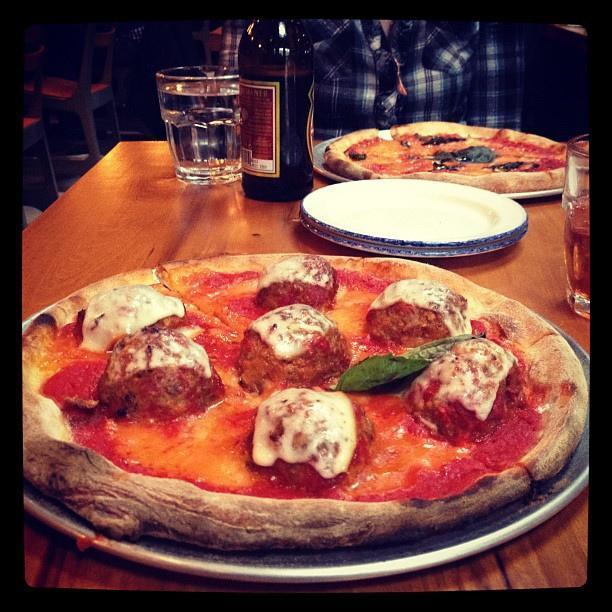How many people are dining?
Give a very brief answer. 2. How many bottles can be seen?
Give a very brief answer. 1. How many cups can be seen?
Give a very brief answer. 2. How many pizzas are visible?
Give a very brief answer. 2. 